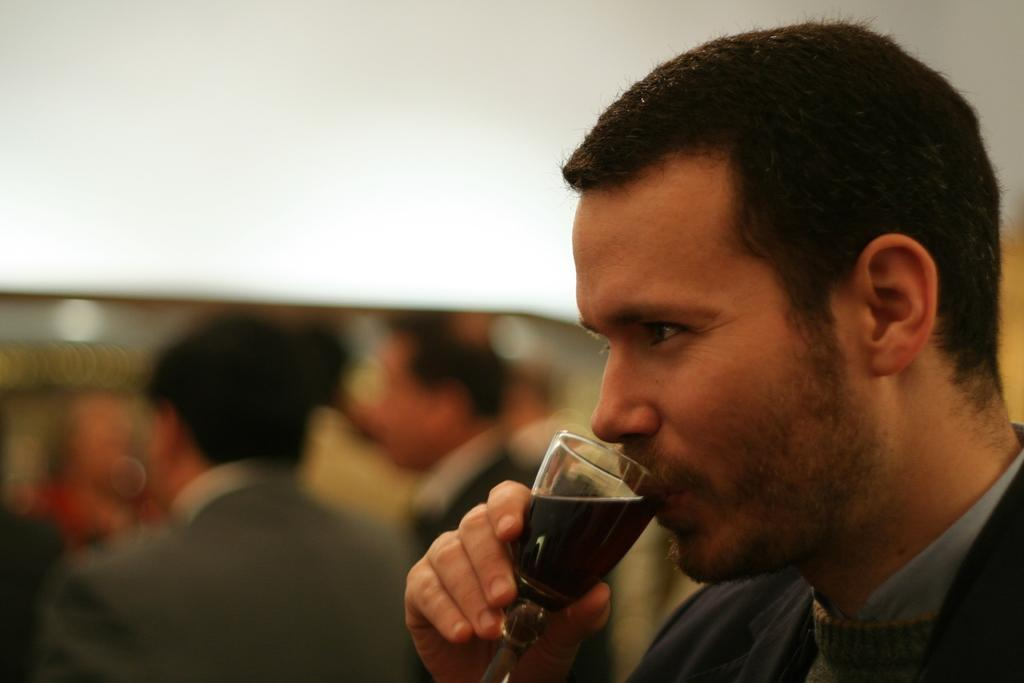What is the man in the image doing? The man in the image is drinking. Can you describe the people on the left side of the image? There are people standing on the left side of the image. What color or feature can be seen at the top of the image? There is a white color wall or curtain at the top of the image. Where is the bear in the image? There is no bear present in the image. What type of field can be seen in the image? There is no field present in the image. 